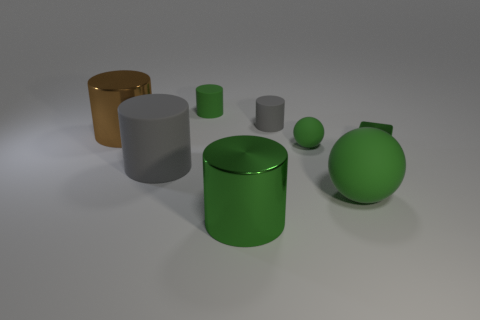Which objects look similar in size and color? The large green cylinder and the green sphere look similar in color, both having a glossy green finish. Size-wise, the small grey cylinder and the grey torus share a similarity in both color and relative dimension. 